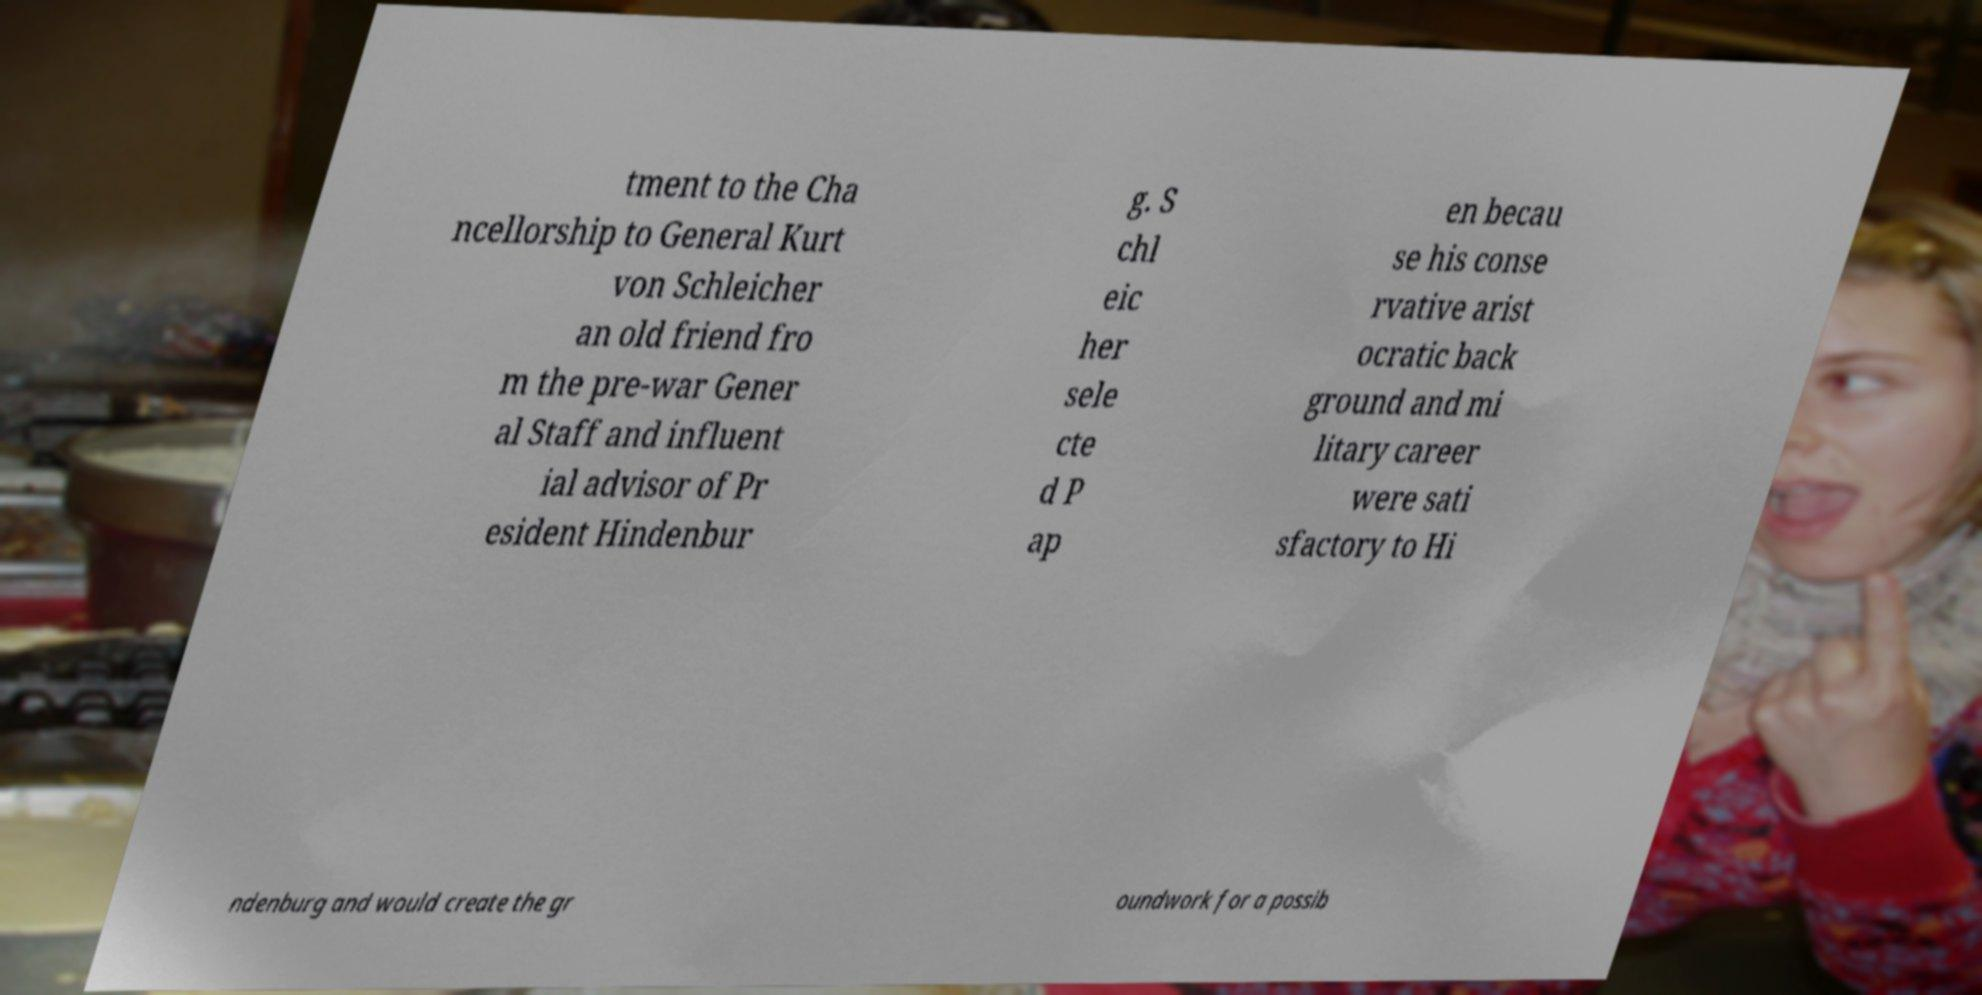Can you read and provide the text displayed in the image?This photo seems to have some interesting text. Can you extract and type it out for me? tment to the Cha ncellorship to General Kurt von Schleicher an old friend fro m the pre-war Gener al Staff and influent ial advisor of Pr esident Hindenbur g. S chl eic her sele cte d P ap en becau se his conse rvative arist ocratic back ground and mi litary career were sati sfactory to Hi ndenburg and would create the gr oundwork for a possib 